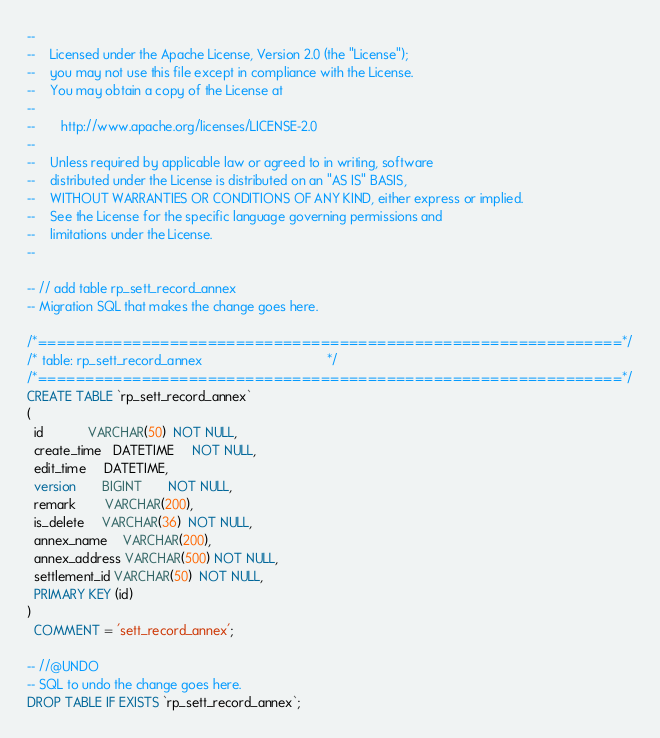Convert code to text. <code><loc_0><loc_0><loc_500><loc_500><_SQL_>--
--    Licensed under the Apache License, Version 2.0 (the "License");
--    you may not use this file except in compliance with the License.
--    You may obtain a copy of the License at
--
--       http://www.apache.org/licenses/LICENSE-2.0
--
--    Unless required by applicable law or agreed to in writing, software
--    distributed under the License is distributed on an "AS IS" BASIS,
--    WITHOUT WARRANTIES OR CONDITIONS OF ANY KIND, either express or implied.
--    See the License for the specific language governing permissions and
--    limitations under the License.
--

-- // add table rp_sett_record_annex
-- Migration SQL that makes the change goes here.

/*==============================================================*/
/* table: rp_sett_record_annex                                  */
/*==============================================================*/
CREATE TABLE `rp_sett_record_annex`
(
  id            VARCHAR(50)  NOT NULL,
  create_time   DATETIME     NOT NULL,
  edit_time     DATETIME,
  version       BIGINT       NOT NULL,
  remark        VARCHAR(200),
  is_delete     VARCHAR(36)  NOT NULL,
  annex_name    VARCHAR(200),
  annex_address VARCHAR(500) NOT NULL,
  settlement_id VARCHAR(50)  NOT NULL,
  PRIMARY KEY (id)
)
  COMMENT = 'sett_record_annex';

-- //@UNDO
-- SQL to undo the change goes here.
DROP TABLE IF EXISTS `rp_sett_record_annex`;

</code> 